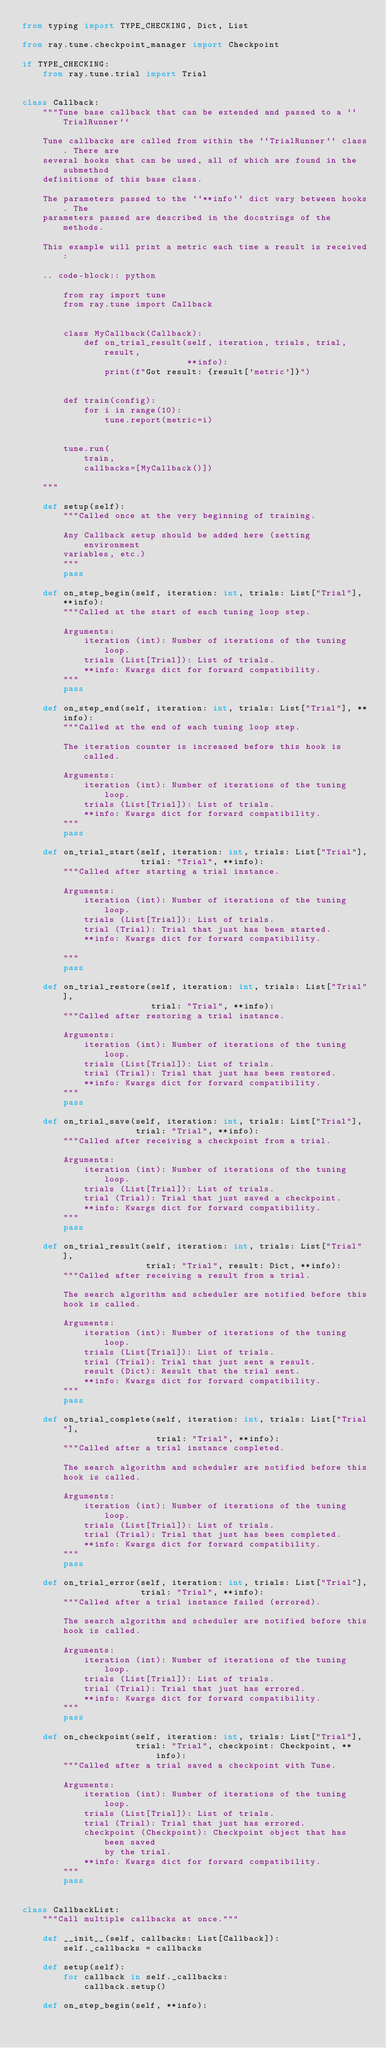Convert code to text. <code><loc_0><loc_0><loc_500><loc_500><_Python_>from typing import TYPE_CHECKING, Dict, List

from ray.tune.checkpoint_manager import Checkpoint

if TYPE_CHECKING:
    from ray.tune.trial import Trial


class Callback:
    """Tune base callback that can be extended and passed to a ``TrialRunner``

    Tune callbacks are called from within the ``TrialRunner`` class. There are
    several hooks that can be used, all of which are found in the submethod
    definitions of this base class.

    The parameters passed to the ``**info`` dict vary between hooks. The
    parameters passed are described in the docstrings of the methods.

    This example will print a metric each time a result is received:

    .. code-block:: python

        from ray import tune
        from ray.tune import Callback


        class MyCallback(Callback):
            def on_trial_result(self, iteration, trials, trial, result,
                                **info):
                print(f"Got result: {result['metric']}")


        def train(config):
            for i in range(10):
                tune.report(metric=i)


        tune.run(
            train,
            callbacks=[MyCallback()])

    """

    def setup(self):
        """Called once at the very beginning of training.

        Any Callback setup should be added here (setting environment
        variables, etc.)
        """
        pass

    def on_step_begin(self, iteration: int, trials: List["Trial"], **info):
        """Called at the start of each tuning loop step.

        Arguments:
            iteration (int): Number of iterations of the tuning loop.
            trials (List[Trial]): List of trials.
            **info: Kwargs dict for forward compatibility.
        """
        pass

    def on_step_end(self, iteration: int, trials: List["Trial"], **info):
        """Called at the end of each tuning loop step.

        The iteration counter is increased before this hook is called.

        Arguments:
            iteration (int): Number of iterations of the tuning loop.
            trials (List[Trial]): List of trials.
            **info: Kwargs dict for forward compatibility.
        """
        pass

    def on_trial_start(self, iteration: int, trials: List["Trial"],
                       trial: "Trial", **info):
        """Called after starting a trial instance.

        Arguments:
            iteration (int): Number of iterations of the tuning loop.
            trials (List[Trial]): List of trials.
            trial (Trial): Trial that just has been started.
            **info: Kwargs dict for forward compatibility.

        """
        pass

    def on_trial_restore(self, iteration: int, trials: List["Trial"],
                         trial: "Trial", **info):
        """Called after restoring a trial instance.

        Arguments:
            iteration (int): Number of iterations of the tuning loop.
            trials (List[Trial]): List of trials.
            trial (Trial): Trial that just has been restored.
            **info: Kwargs dict for forward compatibility.
        """
        pass

    def on_trial_save(self, iteration: int, trials: List["Trial"],
                      trial: "Trial", **info):
        """Called after receiving a checkpoint from a trial.

        Arguments:
            iteration (int): Number of iterations of the tuning loop.
            trials (List[Trial]): List of trials.
            trial (Trial): Trial that just saved a checkpoint.
            **info: Kwargs dict for forward compatibility.
        """
        pass

    def on_trial_result(self, iteration: int, trials: List["Trial"],
                        trial: "Trial", result: Dict, **info):
        """Called after receiving a result from a trial.

        The search algorithm and scheduler are notified before this
        hook is called.

        Arguments:
            iteration (int): Number of iterations of the tuning loop.
            trials (List[Trial]): List of trials.
            trial (Trial): Trial that just sent a result.
            result (Dict): Result that the trial sent.
            **info: Kwargs dict for forward compatibility.
        """
        pass

    def on_trial_complete(self, iteration: int, trials: List["Trial"],
                          trial: "Trial", **info):
        """Called after a trial instance completed.

        The search algorithm and scheduler are notified before this
        hook is called.

        Arguments:
            iteration (int): Number of iterations of the tuning loop.
            trials (List[Trial]): List of trials.
            trial (Trial): Trial that just has been completed.
            **info: Kwargs dict for forward compatibility.
        """
        pass

    def on_trial_error(self, iteration: int, trials: List["Trial"],
                       trial: "Trial", **info):
        """Called after a trial instance failed (errored).

        The search algorithm and scheduler are notified before this
        hook is called.

        Arguments:
            iteration (int): Number of iterations of the tuning loop.
            trials (List[Trial]): List of trials.
            trial (Trial): Trial that just has errored.
            **info: Kwargs dict for forward compatibility.
        """
        pass

    def on_checkpoint(self, iteration: int, trials: List["Trial"],
                      trial: "Trial", checkpoint: Checkpoint, **info):
        """Called after a trial saved a checkpoint with Tune.

        Arguments:
            iteration (int): Number of iterations of the tuning loop.
            trials (List[Trial]): List of trials.
            trial (Trial): Trial that just has errored.
            checkpoint (Checkpoint): Checkpoint object that has been saved
                by the trial.
            **info: Kwargs dict for forward compatibility.
        """
        pass


class CallbackList:
    """Call multiple callbacks at once."""

    def __init__(self, callbacks: List[Callback]):
        self._callbacks = callbacks

    def setup(self):
        for callback in self._callbacks:
            callback.setup()

    def on_step_begin(self, **info):</code> 